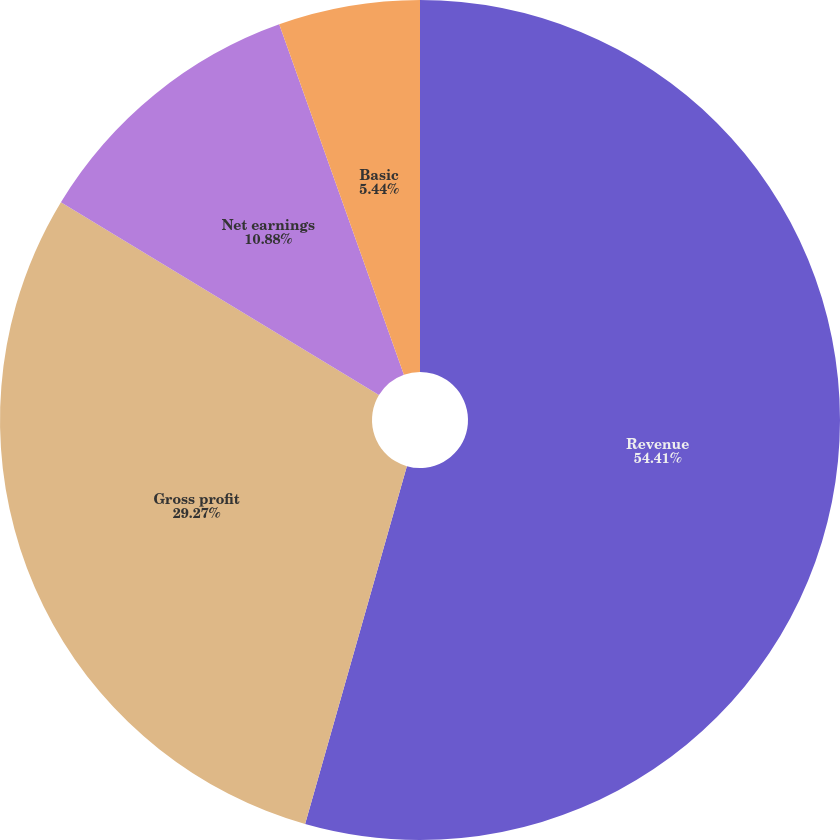<chart> <loc_0><loc_0><loc_500><loc_500><pie_chart><fcel>Revenue<fcel>Gross profit<fcel>Net earnings<fcel>Basic<fcel>Diluted<nl><fcel>54.41%<fcel>29.27%<fcel>10.88%<fcel>5.44%<fcel>0.0%<nl></chart> 